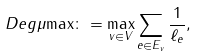<formula> <loc_0><loc_0><loc_500><loc_500>\ D e g { \mu } { \max } \colon = \max _ { v \in V } \sum _ { e \in E _ { v } } \frac { 1 } { \ell _ { e } } ,</formula> 